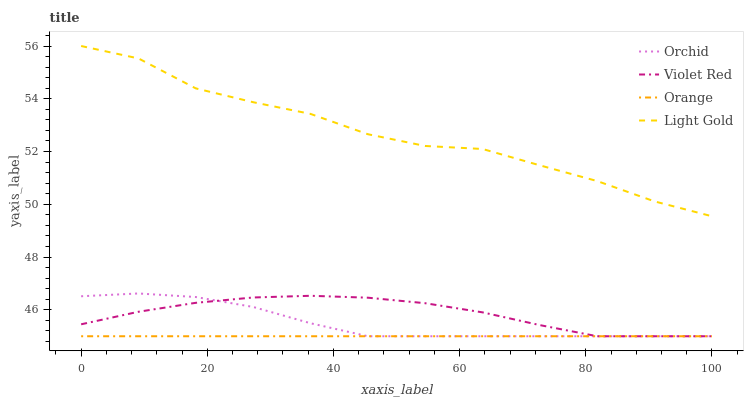Does Orange have the minimum area under the curve?
Answer yes or no. Yes. Does Light Gold have the maximum area under the curve?
Answer yes or no. Yes. Does Violet Red have the minimum area under the curve?
Answer yes or no. No. Does Violet Red have the maximum area under the curve?
Answer yes or no. No. Is Orange the smoothest?
Answer yes or no. Yes. Is Light Gold the roughest?
Answer yes or no. Yes. Is Violet Red the smoothest?
Answer yes or no. No. Is Violet Red the roughest?
Answer yes or no. No. Does Orange have the lowest value?
Answer yes or no. Yes. Does Light Gold have the lowest value?
Answer yes or no. No. Does Light Gold have the highest value?
Answer yes or no. Yes. Does Violet Red have the highest value?
Answer yes or no. No. Is Violet Red less than Light Gold?
Answer yes or no. Yes. Is Light Gold greater than Orange?
Answer yes or no. Yes. Does Orchid intersect Violet Red?
Answer yes or no. Yes. Is Orchid less than Violet Red?
Answer yes or no. No. Is Orchid greater than Violet Red?
Answer yes or no. No. Does Violet Red intersect Light Gold?
Answer yes or no. No. 